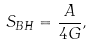Convert formula to latex. <formula><loc_0><loc_0><loc_500><loc_500>S _ { B H } = \frac { A } { 4 G } ,</formula> 